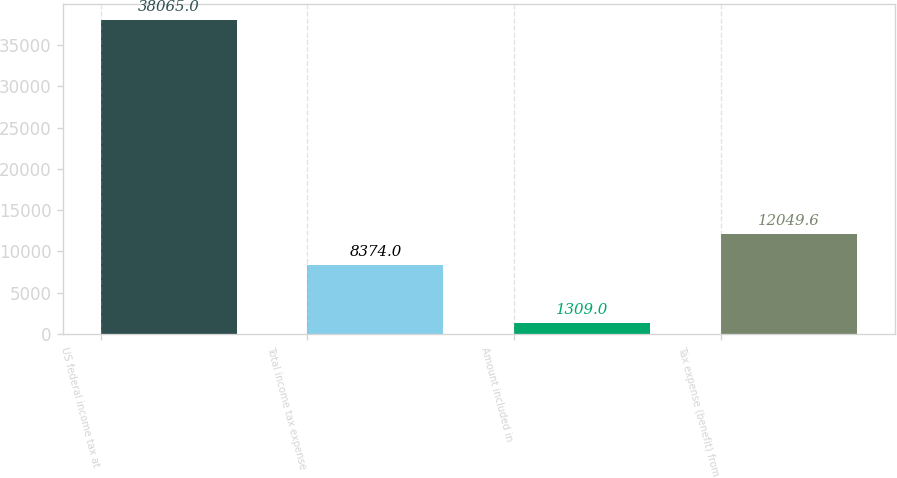Convert chart. <chart><loc_0><loc_0><loc_500><loc_500><bar_chart><fcel>US federal income tax at<fcel>Total income tax expense<fcel>Amount included in<fcel>Tax expense (benefit) from<nl><fcel>38065<fcel>8374<fcel>1309<fcel>12049.6<nl></chart> 